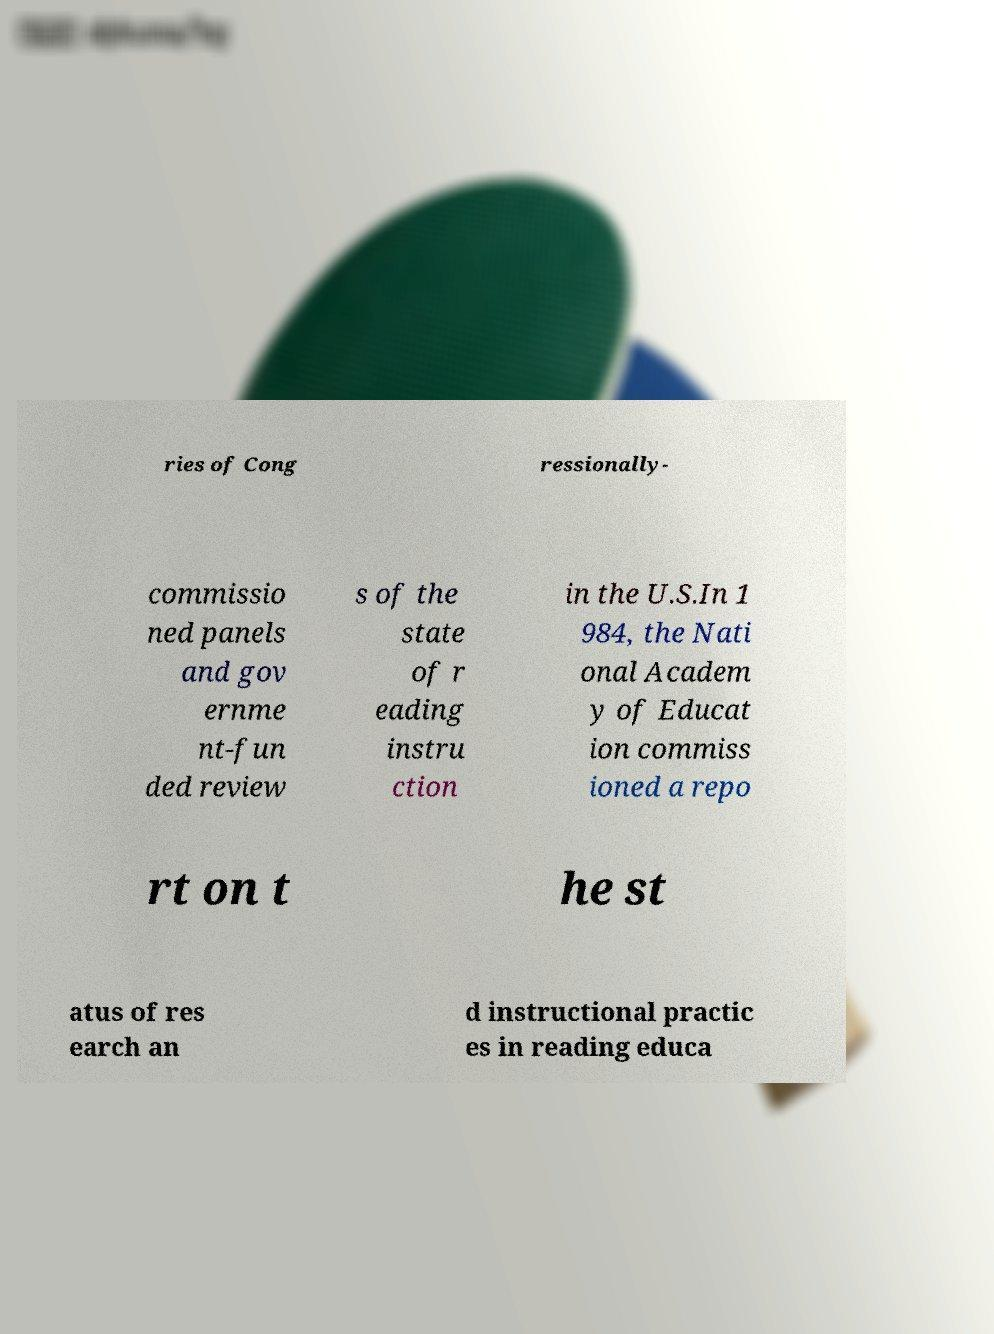There's text embedded in this image that I need extracted. Can you transcribe it verbatim? ries of Cong ressionally- commissio ned panels and gov ernme nt-fun ded review s of the state of r eading instru ction in the U.S.In 1 984, the Nati onal Academ y of Educat ion commiss ioned a repo rt on t he st atus of res earch an d instructional practic es in reading educa 